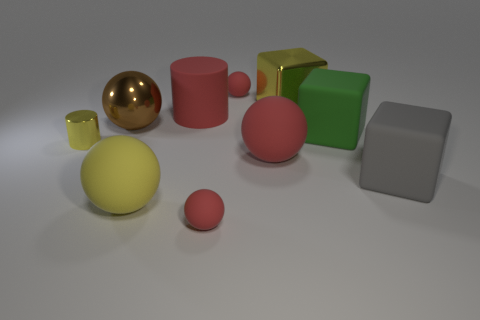Is the number of big matte things greater than the number of shiny cubes?
Your answer should be compact. Yes. What number of other things are there of the same material as the big cylinder
Your answer should be compact. 6. What number of things are large shiny balls or large objects that are to the right of the big brown ball?
Give a very brief answer. 7. Is the number of big yellow metallic blocks less than the number of tiny green shiny blocks?
Your answer should be compact. No. The block on the right side of the large green rubber object that is to the right of the yellow thing that is behind the large green matte block is what color?
Your answer should be very brief. Gray. Is the material of the large brown ball the same as the large yellow block?
Provide a short and direct response. Yes. There is a yellow block; how many metal things are in front of it?
Offer a terse response. 2. What is the size of the red thing that is the same shape as the tiny yellow object?
Make the answer very short. Large. What number of green things are rubber objects or matte spheres?
Give a very brief answer. 1. How many green blocks are behind the yellow metallic object that is behind the metal sphere?
Your answer should be very brief. 0. 